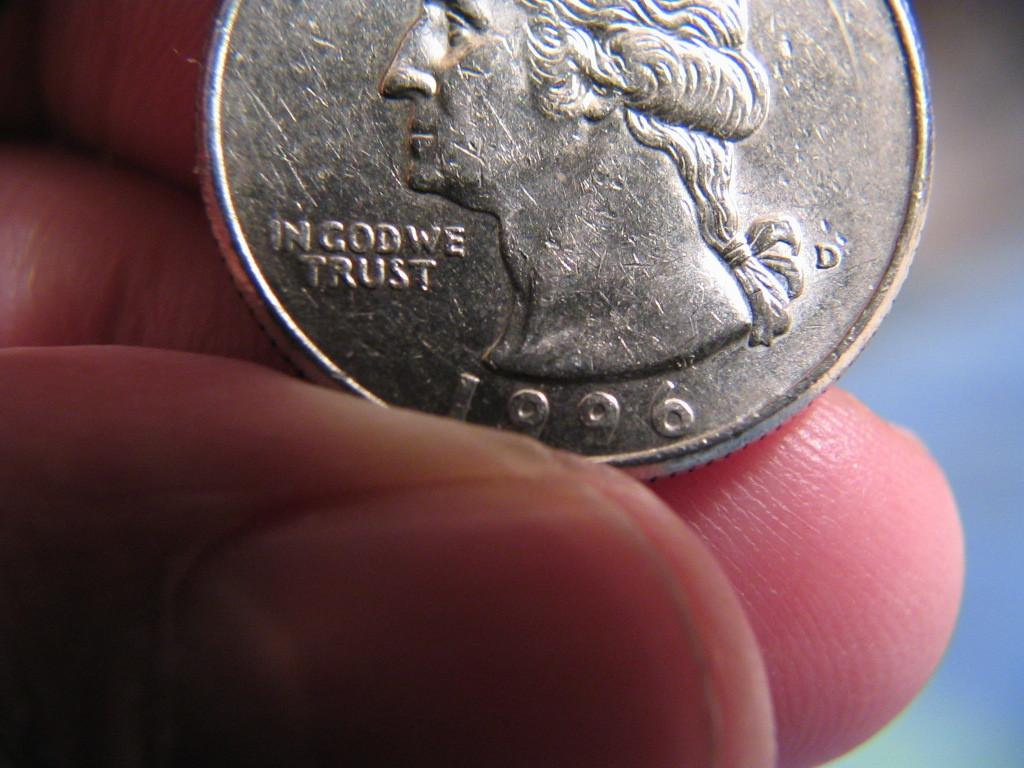<image>
Present a compact description of the photo's key features. The front view of a 1996 U.S. quarter. 